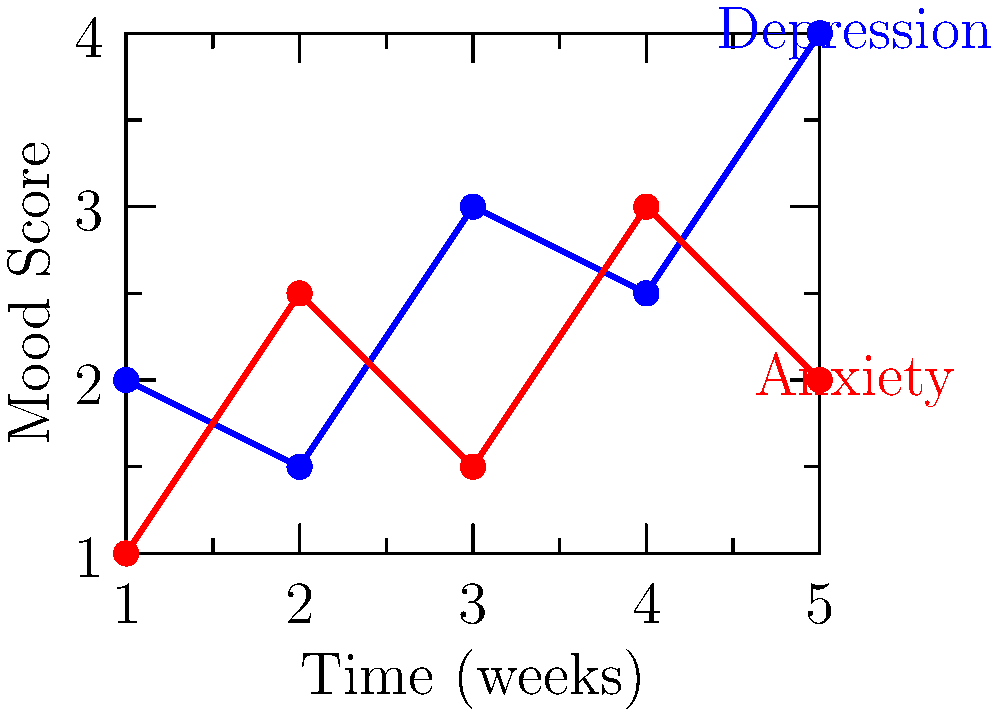Based on the graph showing mood scores over time for depression and anxiety, which mental health condition appears to have a more consistent trend, and what might this suggest about the patient's emotional state? To answer this question, we need to analyze the trends for both depression and anxiety:

1. Depression (blue line):
   - Starts at 2, drops to 1.5, rises to 3, drops to 2.5, then rises to 4
   - Shows significant fluctuations with no clear consistent trend

2. Anxiety (red line):
   - Starts at 1, rises to 2.5, drops to 1.5, rises to 3, then drops to 2
   - Also shows fluctuations, but with less extreme changes

3. Comparing the two:
   - Anxiety shows slightly more consistent up-and-down pattern
   - Depression has more extreme highs and lows

4. Interpretation:
   - The more consistent trend in anxiety scores suggests a more predictable pattern of worry or stress
   - The fluctuating depression scores might indicate more volatile mood changes related to depressive symptoms

5. Conclusion:
   Anxiety appears to have a more consistent trend, suggesting the patient may be experiencing ongoing, steady levels of worry or stress, while their depressive symptoms seem to be more variable and intense.
Answer: Anxiety; suggests ongoing, steady stress levels 